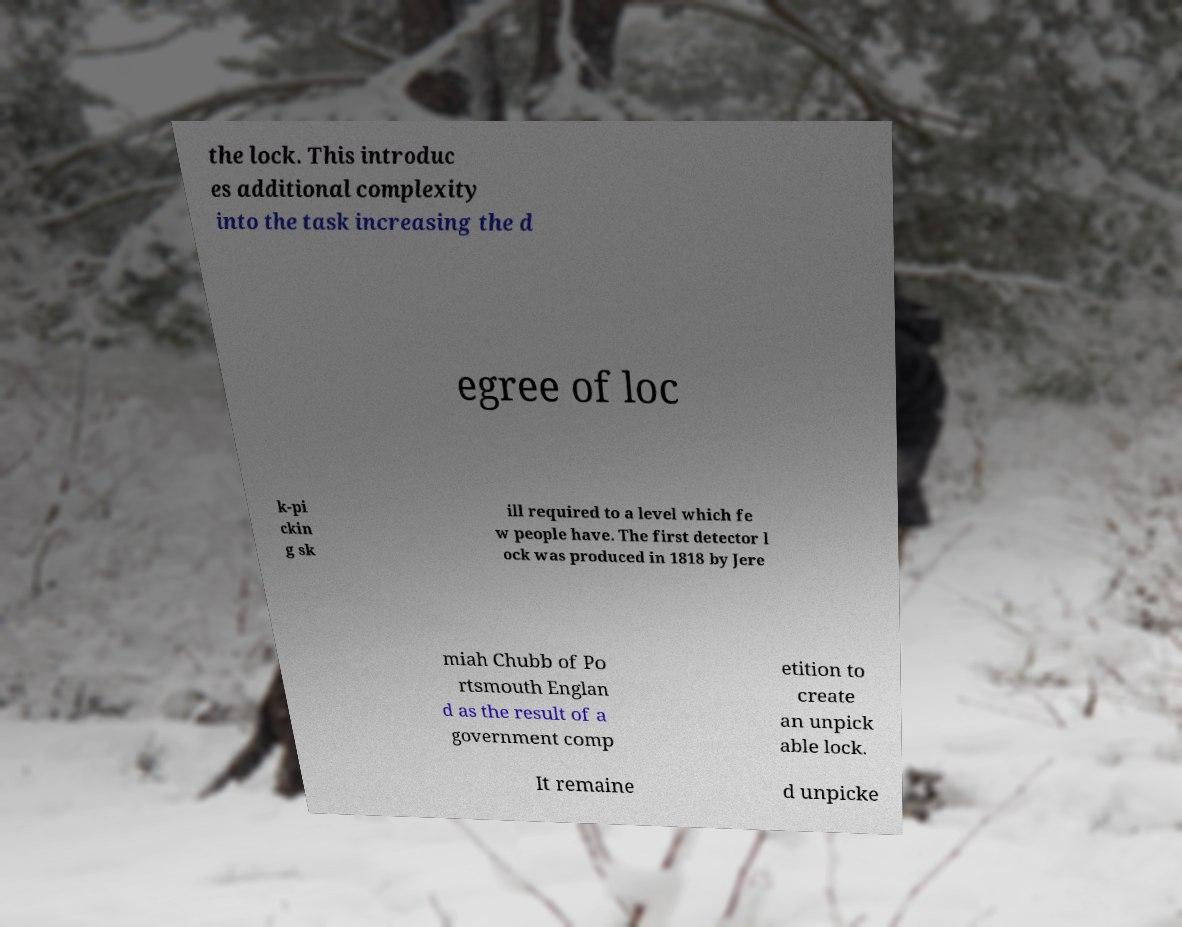Could you extract and type out the text from this image? the lock. This introduc es additional complexity into the task increasing the d egree of loc k-pi ckin g sk ill required to a level which fe w people have. The first detector l ock was produced in 1818 by Jere miah Chubb of Po rtsmouth Englan d as the result of a government comp etition to create an unpick able lock. It remaine d unpicke 